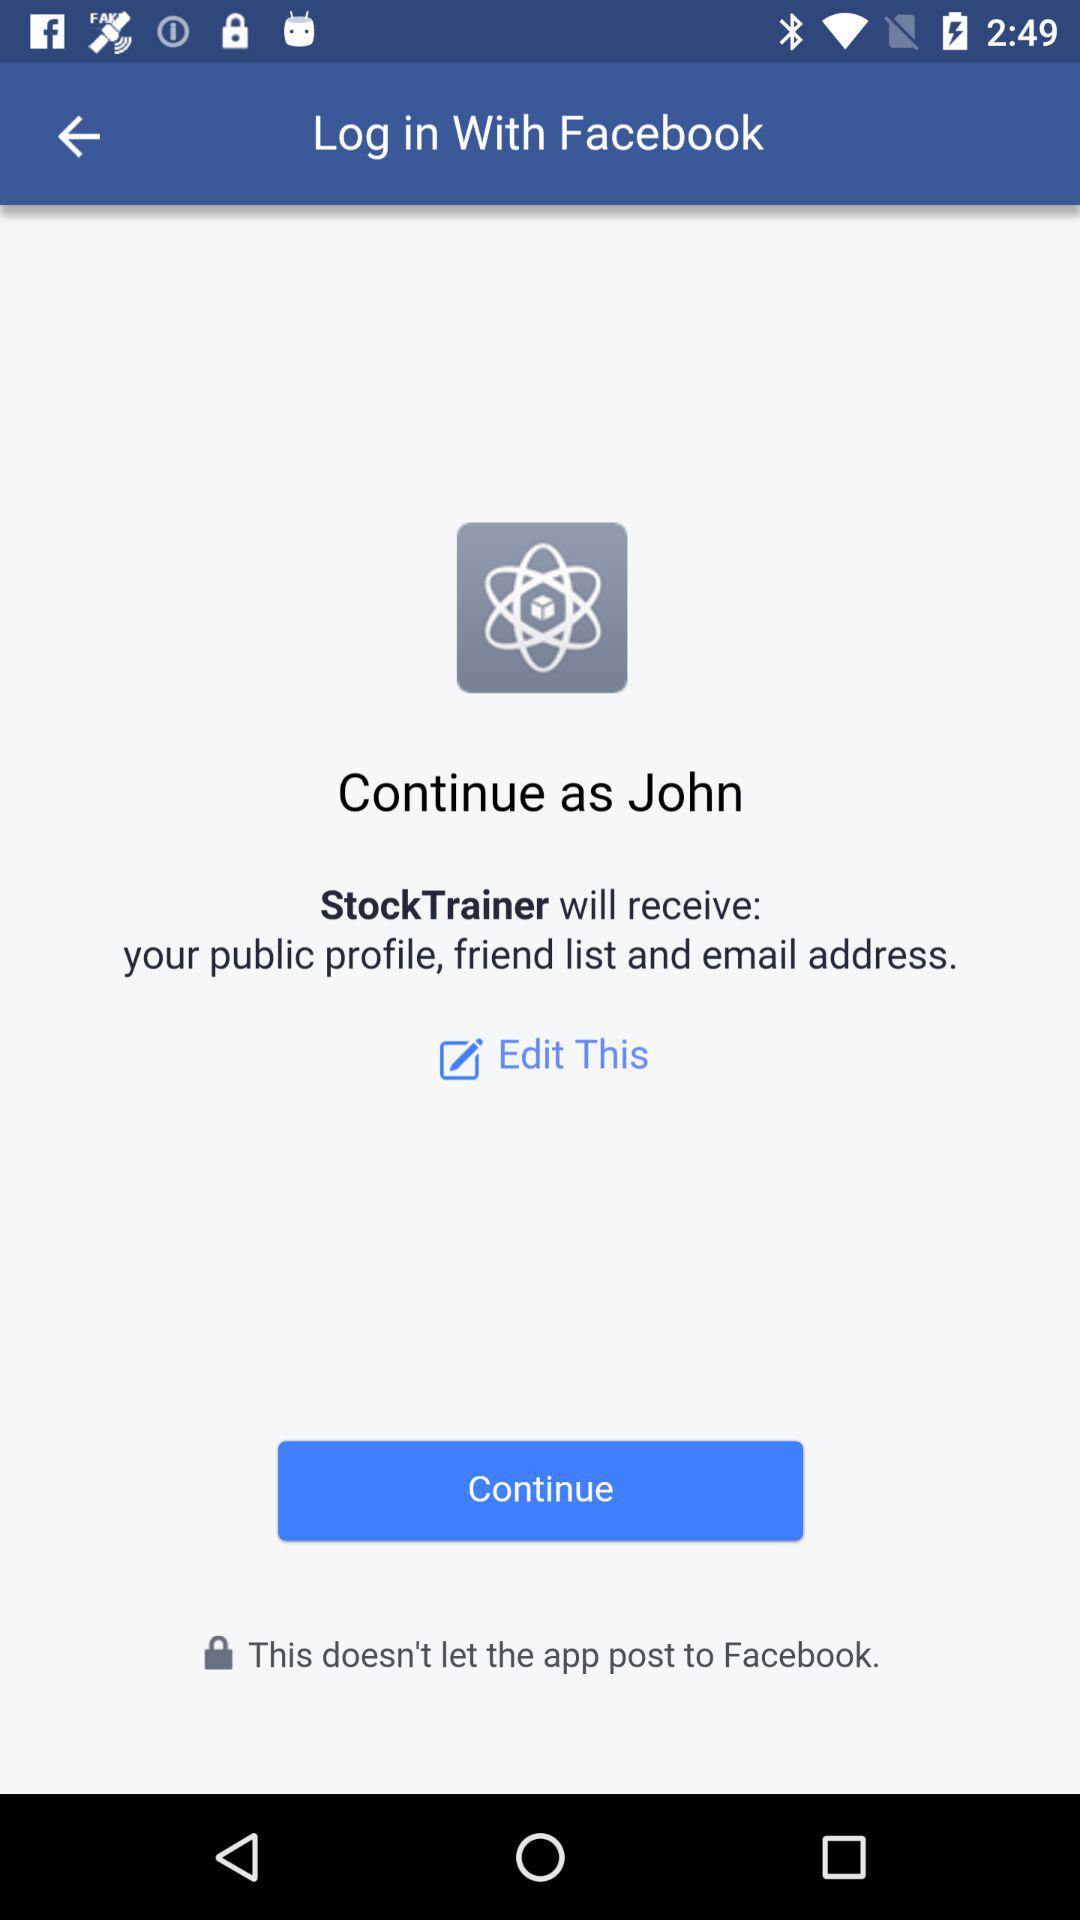What is the name of the user? The name of the user is John. 